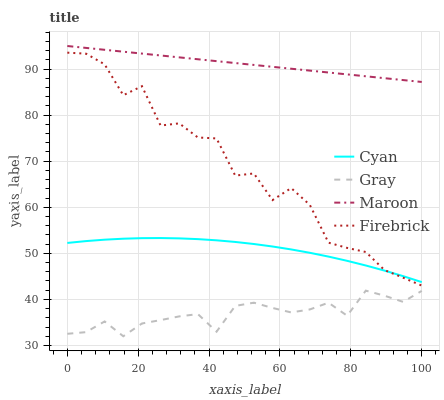Does Gray have the minimum area under the curve?
Answer yes or no. Yes. Does Maroon have the maximum area under the curve?
Answer yes or no. Yes. Does Firebrick have the minimum area under the curve?
Answer yes or no. No. Does Firebrick have the maximum area under the curve?
Answer yes or no. No. Is Maroon the smoothest?
Answer yes or no. Yes. Is Firebrick the roughest?
Answer yes or no. Yes. Is Firebrick the smoothest?
Answer yes or no. No. Is Maroon the roughest?
Answer yes or no. No. Does Firebrick have the lowest value?
Answer yes or no. No. Does Maroon have the highest value?
Answer yes or no. Yes. Does Firebrick have the highest value?
Answer yes or no. No. Is Cyan less than Maroon?
Answer yes or no. Yes. Is Firebrick greater than Gray?
Answer yes or no. Yes. Does Firebrick intersect Cyan?
Answer yes or no. Yes. Is Firebrick less than Cyan?
Answer yes or no. No. Is Firebrick greater than Cyan?
Answer yes or no. No. Does Cyan intersect Maroon?
Answer yes or no. No. 